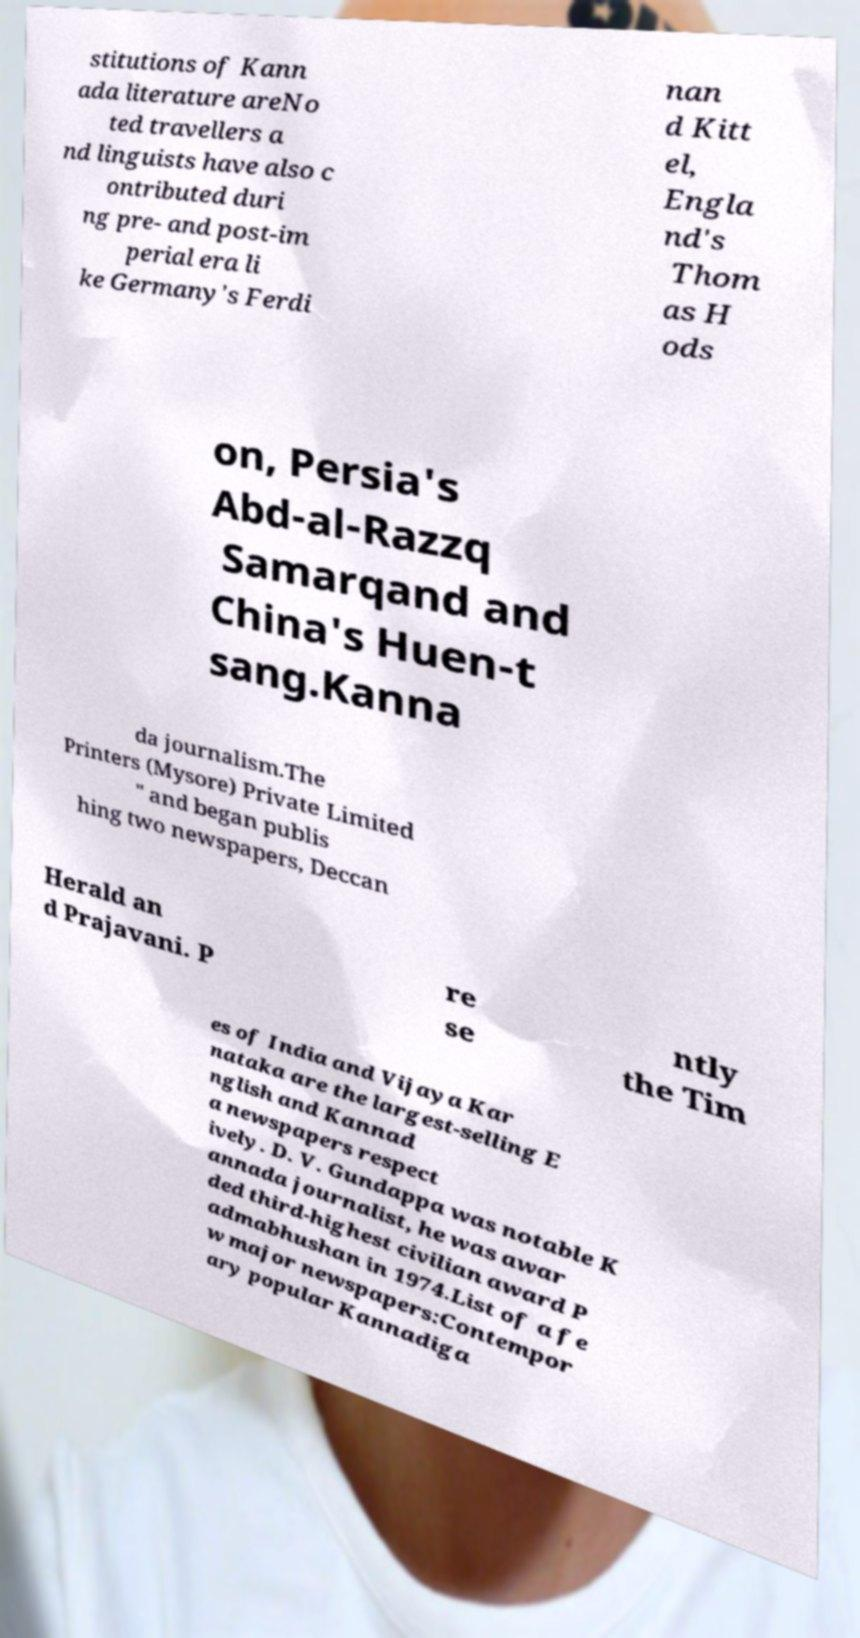Can you accurately transcribe the text from the provided image for me? stitutions of Kann ada literature areNo ted travellers a nd linguists have also c ontributed duri ng pre- and post-im perial era li ke Germany's Ferdi nan d Kitt el, Engla nd's Thom as H ods on, Persia's Abd-al-Razzq Samarqand and China's Huen-t sang.Kanna da journalism.The Printers (Mysore) Private Limited " and began publis hing two newspapers, Deccan Herald an d Prajavani. P re se ntly the Tim es of India and Vijaya Kar nataka are the largest-selling E nglish and Kannad a newspapers respect ively. D. V. Gundappa was notable K annada journalist, he was awar ded third-highest civilian award P admabhushan in 1974.List of a fe w major newspapers:Contempor ary popular Kannadiga 